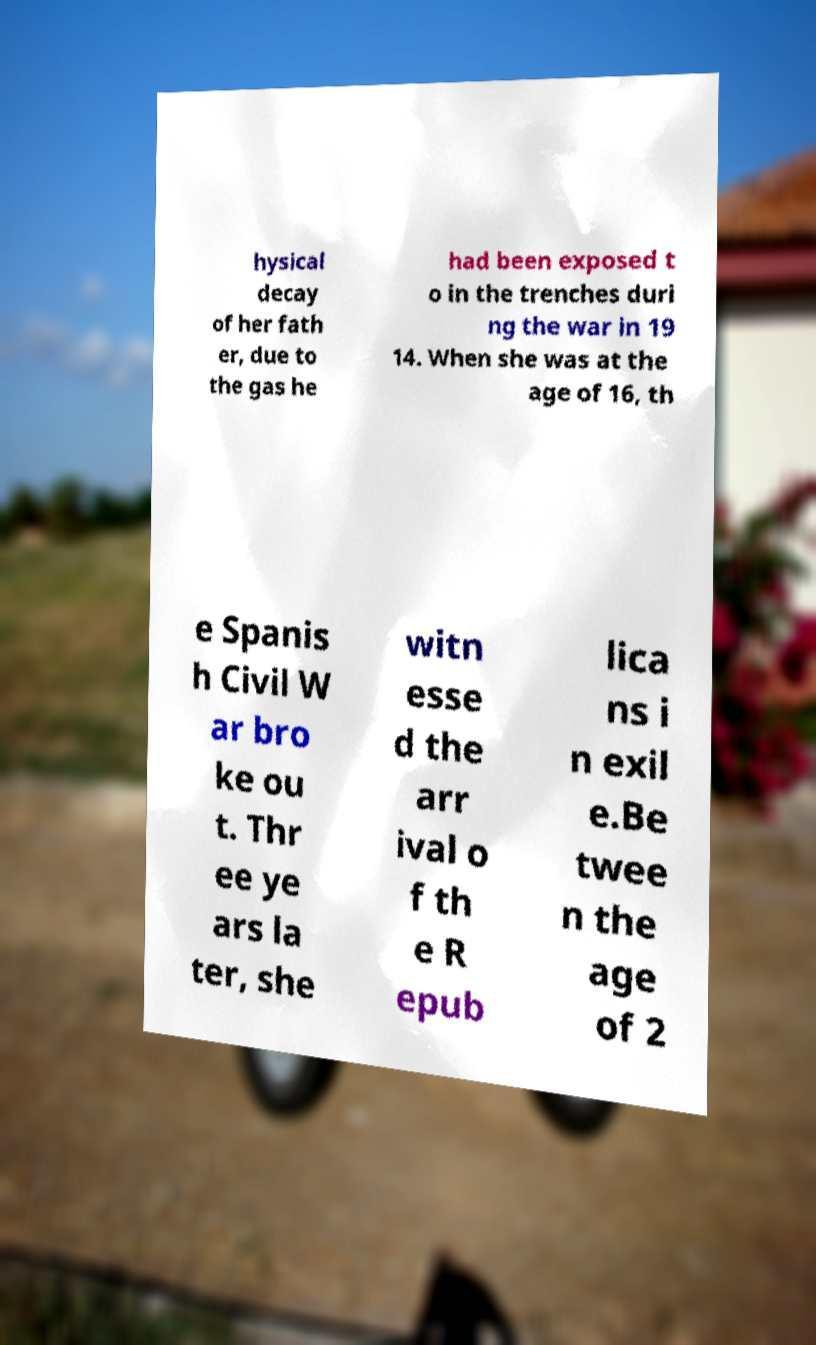Could you assist in decoding the text presented in this image and type it out clearly? hysical decay of her fath er, due to the gas he had been exposed t o in the trenches duri ng the war in 19 14. When she was at the age of 16, th e Spanis h Civil W ar bro ke ou t. Thr ee ye ars la ter, she witn esse d the arr ival o f th e R epub lica ns i n exil e.Be twee n the age of 2 